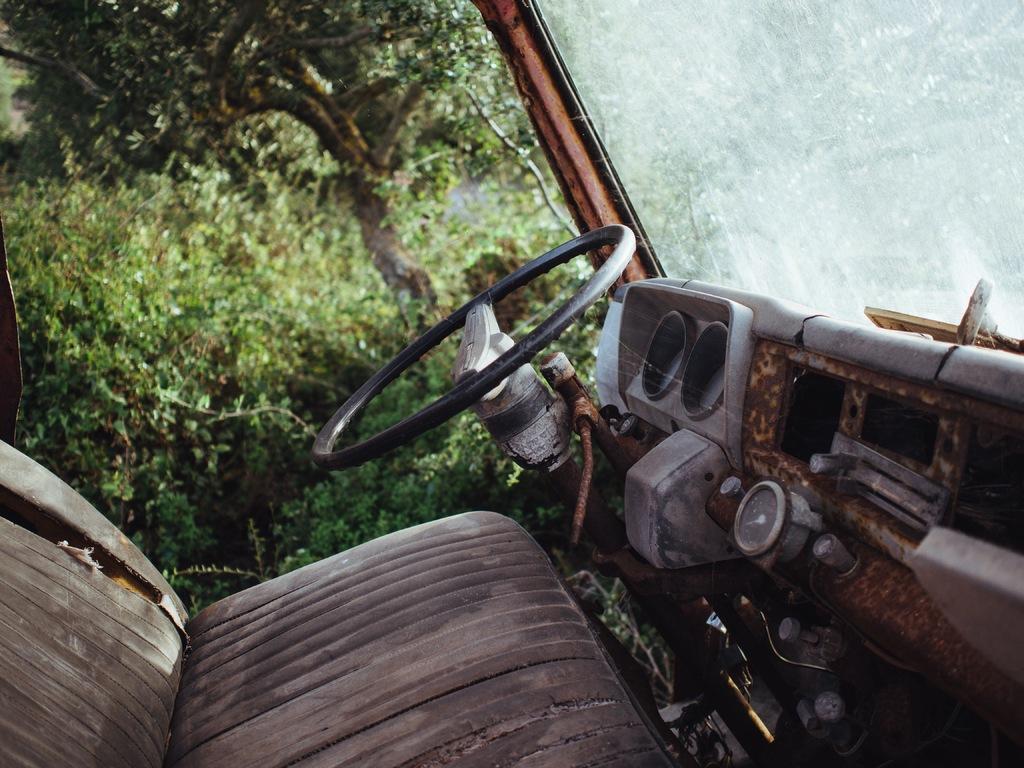Describe this image in one or two sentences. In this picture, we see the seat of the vehicle, steering wheel and the dashboard of the vehicle. In the right top, we see the glass. There are trees in the background. This picture is clicked in the vehicle. 